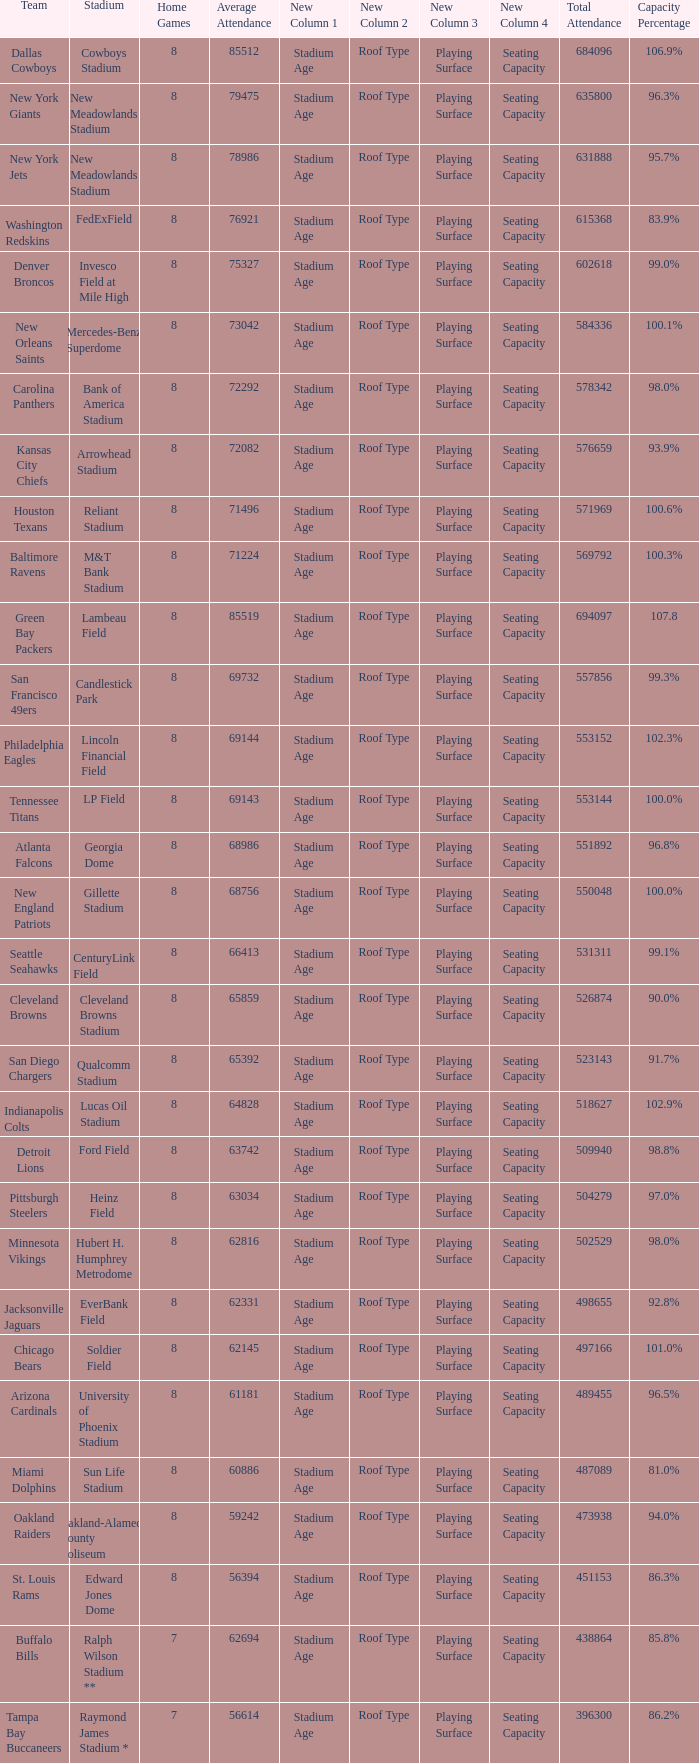How many average attendance has a capacity percentage of 96.5% 1.0. Give me the full table as a dictionary. {'header': ['Team', 'Stadium', 'Home Games', 'Average Attendance', 'New Column 1', 'New Column 2', 'New Column 3', 'New Column 4', 'Total Attendance', 'Capacity Percentage'], 'rows': [['Dallas Cowboys', 'Cowboys Stadium', '8', '85512', 'Stadium Age', 'Roof Type', 'Playing Surface', 'Seating Capacity', '684096', '106.9%'], ['New York Giants', 'New Meadowlands Stadium', '8', '79475', 'Stadium Age', 'Roof Type', 'Playing Surface', 'Seating Capacity', '635800', '96.3%'], ['New York Jets', 'New Meadowlands Stadium', '8', '78986', 'Stadium Age', 'Roof Type', 'Playing Surface', 'Seating Capacity', '631888', '95.7%'], ['Washington Redskins', 'FedExField', '8', '76921', 'Stadium Age', 'Roof Type', 'Playing Surface', 'Seating Capacity', '615368', '83.9%'], ['Denver Broncos', 'Invesco Field at Mile High', '8', '75327', 'Stadium Age', 'Roof Type', 'Playing Surface', 'Seating Capacity', '602618', '99.0%'], ['New Orleans Saints', 'Mercedes-Benz Superdome', '8', '73042', 'Stadium Age', 'Roof Type', 'Playing Surface', 'Seating Capacity', '584336', '100.1%'], ['Carolina Panthers', 'Bank of America Stadium', '8', '72292', 'Stadium Age', 'Roof Type', 'Playing Surface', 'Seating Capacity', '578342', '98.0%'], ['Kansas City Chiefs', 'Arrowhead Stadium', '8', '72082', 'Stadium Age', 'Roof Type', 'Playing Surface', 'Seating Capacity', '576659', '93.9%'], ['Houston Texans', 'Reliant Stadium', '8', '71496', 'Stadium Age', 'Roof Type', 'Playing Surface', 'Seating Capacity', '571969', '100.6%'], ['Baltimore Ravens', 'M&T Bank Stadium', '8', '71224', 'Stadium Age', 'Roof Type', 'Playing Surface', 'Seating Capacity', '569792', '100.3%'], ['Green Bay Packers', 'Lambeau Field', '8', '85519', 'Stadium Age', 'Roof Type', 'Playing Surface', 'Seating Capacity', '694097', '107.8'], ['San Francisco 49ers', 'Candlestick Park', '8', '69732', 'Stadium Age', 'Roof Type', 'Playing Surface', 'Seating Capacity', '557856', '99.3%'], ['Philadelphia Eagles', 'Lincoln Financial Field', '8', '69144', 'Stadium Age', 'Roof Type', 'Playing Surface', 'Seating Capacity', '553152', '102.3%'], ['Tennessee Titans', 'LP Field', '8', '69143', 'Stadium Age', 'Roof Type', 'Playing Surface', 'Seating Capacity', '553144', '100.0%'], ['Atlanta Falcons', 'Georgia Dome', '8', '68986', 'Stadium Age', 'Roof Type', 'Playing Surface', 'Seating Capacity', '551892', '96.8%'], ['New England Patriots', 'Gillette Stadium', '8', '68756', 'Stadium Age', 'Roof Type', 'Playing Surface', 'Seating Capacity', '550048', '100.0%'], ['Seattle Seahawks', 'CenturyLink Field', '8', '66413', 'Stadium Age', 'Roof Type', 'Playing Surface', 'Seating Capacity', '531311', '99.1%'], ['Cleveland Browns', 'Cleveland Browns Stadium', '8', '65859', 'Stadium Age', 'Roof Type', 'Playing Surface', 'Seating Capacity', '526874', '90.0%'], ['San Diego Chargers', 'Qualcomm Stadium', '8', '65392', 'Stadium Age', 'Roof Type', 'Playing Surface', 'Seating Capacity', '523143', '91.7%'], ['Indianapolis Colts', 'Lucas Oil Stadium', '8', '64828', 'Stadium Age', 'Roof Type', 'Playing Surface', 'Seating Capacity', '518627', '102.9%'], ['Detroit Lions', 'Ford Field', '8', '63742', 'Stadium Age', 'Roof Type', 'Playing Surface', 'Seating Capacity', '509940', '98.8%'], ['Pittsburgh Steelers', 'Heinz Field', '8', '63034', 'Stadium Age', 'Roof Type', 'Playing Surface', 'Seating Capacity', '504279', '97.0%'], ['Minnesota Vikings', 'Hubert H. Humphrey Metrodome', '8', '62816', 'Stadium Age', 'Roof Type', 'Playing Surface', 'Seating Capacity', '502529', '98.0%'], ['Jacksonville Jaguars', 'EverBank Field', '8', '62331', 'Stadium Age', 'Roof Type', 'Playing Surface', 'Seating Capacity', '498655', '92.8%'], ['Chicago Bears', 'Soldier Field', '8', '62145', 'Stadium Age', 'Roof Type', 'Playing Surface', 'Seating Capacity', '497166', '101.0%'], ['Arizona Cardinals', 'University of Phoenix Stadium', '8', '61181', 'Stadium Age', 'Roof Type', 'Playing Surface', 'Seating Capacity', '489455', '96.5%'], ['Miami Dolphins', 'Sun Life Stadium', '8', '60886', 'Stadium Age', 'Roof Type', 'Playing Surface', 'Seating Capacity', '487089', '81.0%'], ['Oakland Raiders', 'Oakland-Alameda County Coliseum', '8', '59242', 'Stadium Age', 'Roof Type', 'Playing Surface', 'Seating Capacity', '473938', '94.0%'], ['St. Louis Rams', 'Edward Jones Dome', '8', '56394', 'Stadium Age', 'Roof Type', 'Playing Surface', 'Seating Capacity', '451153', '86.3%'], ['Buffalo Bills', 'Ralph Wilson Stadium **', '7', '62694', 'Stadium Age', 'Roof Type', 'Playing Surface', 'Seating Capacity', '438864', '85.8%'], ['Tampa Bay Buccaneers', 'Raymond James Stadium *', '7', '56614', 'Stadium Age', 'Roof Type', 'Playing Surface', 'Seating Capacity', '396300', '86.2%']]} 